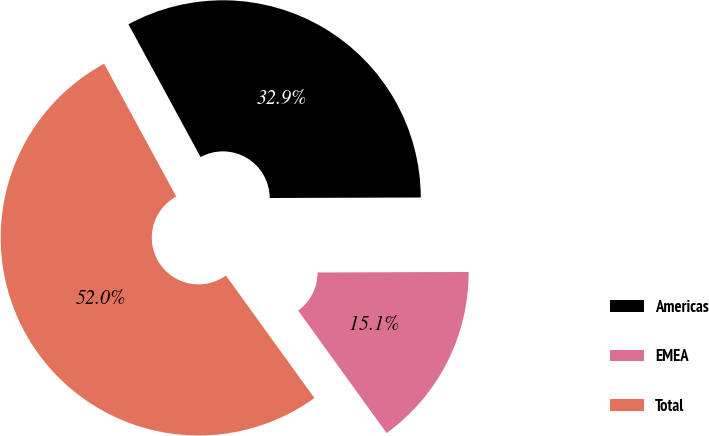Convert chart to OTSL. <chart><loc_0><loc_0><loc_500><loc_500><pie_chart><fcel>Americas<fcel>EMEA<fcel>Total<nl><fcel>32.87%<fcel>15.1%<fcel>52.03%<nl></chart> 